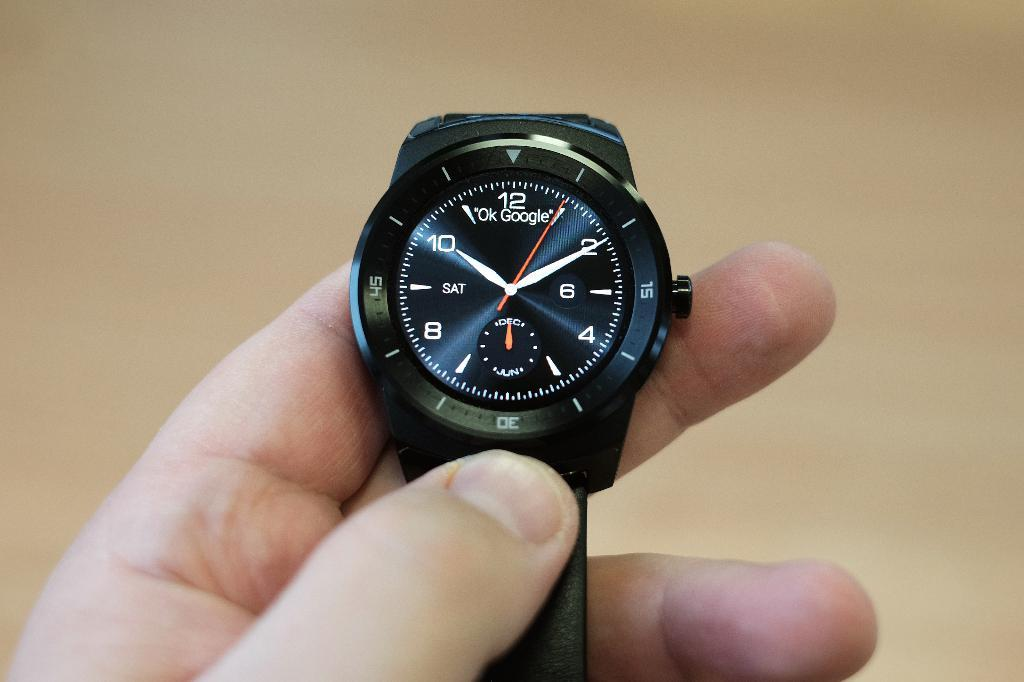<image>
Present a compact description of the photo's key features. A watch has the Ok Google logo on the face. 